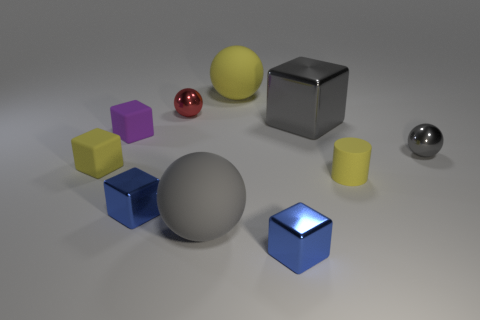Is there any other thing that has the same color as the large metallic thing?
Ensure brevity in your answer.  Yes. Are there the same number of big gray metal things in front of the large gray shiny object and blue shiny blocks on the right side of the tiny yellow cylinder?
Offer a very short reply. Yes. There is a tiny ball left of the tiny gray object; is there a gray shiny ball that is to the left of it?
Your response must be concise. No. The small purple rubber thing is what shape?
Give a very brief answer. Cube. There is a sphere that is the same color as the small rubber cylinder; what size is it?
Provide a short and direct response. Large. There is a blue metallic thing in front of the big ball in front of the large shiny cube; what is its size?
Offer a terse response. Small. What is the size of the shiny ball right of the big yellow thing?
Offer a terse response. Small. Are there fewer tiny blue metal cubes behind the big gray metal thing than small yellow rubber cylinders behind the red ball?
Your answer should be very brief. No. The big block is what color?
Keep it short and to the point. Gray. Is there a big matte ball of the same color as the small matte cylinder?
Your answer should be compact. Yes. 